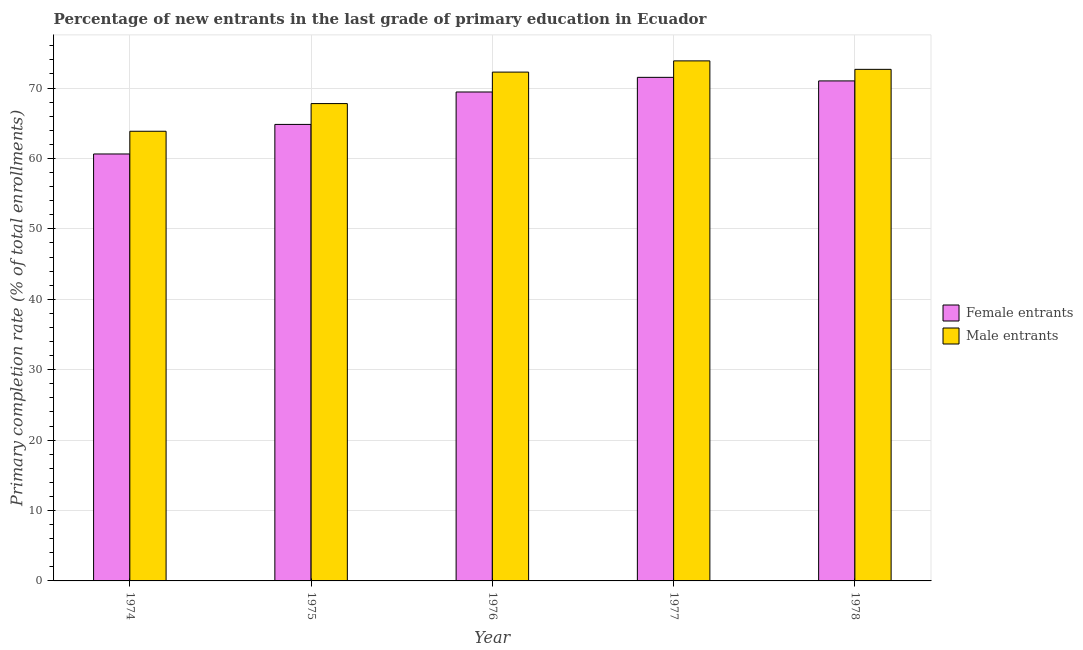How many different coloured bars are there?
Ensure brevity in your answer.  2. How many groups of bars are there?
Offer a very short reply. 5. Are the number of bars per tick equal to the number of legend labels?
Your answer should be very brief. Yes. How many bars are there on the 2nd tick from the left?
Your answer should be compact. 2. How many bars are there on the 2nd tick from the right?
Provide a short and direct response. 2. What is the label of the 4th group of bars from the left?
Ensure brevity in your answer.  1977. In how many cases, is the number of bars for a given year not equal to the number of legend labels?
Your response must be concise. 0. What is the primary completion rate of female entrants in 1978?
Ensure brevity in your answer.  71.01. Across all years, what is the maximum primary completion rate of female entrants?
Offer a terse response. 71.52. Across all years, what is the minimum primary completion rate of female entrants?
Your response must be concise. 60.64. In which year was the primary completion rate of male entrants minimum?
Make the answer very short. 1974. What is the total primary completion rate of female entrants in the graph?
Ensure brevity in your answer.  337.44. What is the difference between the primary completion rate of female entrants in 1974 and that in 1977?
Give a very brief answer. -10.88. What is the difference between the primary completion rate of female entrants in 1975 and the primary completion rate of male entrants in 1977?
Provide a succinct answer. -6.68. What is the average primary completion rate of female entrants per year?
Offer a very short reply. 67.49. What is the ratio of the primary completion rate of female entrants in 1974 to that in 1976?
Your answer should be very brief. 0.87. Is the primary completion rate of male entrants in 1974 less than that in 1976?
Your response must be concise. Yes. Is the difference between the primary completion rate of male entrants in 1974 and 1977 greater than the difference between the primary completion rate of female entrants in 1974 and 1977?
Offer a terse response. No. What is the difference between the highest and the second highest primary completion rate of male entrants?
Your answer should be compact. 1.2. What is the difference between the highest and the lowest primary completion rate of male entrants?
Your response must be concise. 10. In how many years, is the primary completion rate of female entrants greater than the average primary completion rate of female entrants taken over all years?
Keep it short and to the point. 3. What does the 2nd bar from the left in 1977 represents?
Make the answer very short. Male entrants. What does the 2nd bar from the right in 1976 represents?
Provide a succinct answer. Female entrants. How many years are there in the graph?
Keep it short and to the point. 5. What is the difference between two consecutive major ticks on the Y-axis?
Provide a succinct answer. 10. Are the values on the major ticks of Y-axis written in scientific E-notation?
Keep it short and to the point. No. Does the graph contain any zero values?
Make the answer very short. No. Does the graph contain grids?
Provide a succinct answer. Yes. Where does the legend appear in the graph?
Ensure brevity in your answer.  Center right. What is the title of the graph?
Make the answer very short. Percentage of new entrants in the last grade of primary education in Ecuador. What is the label or title of the X-axis?
Provide a succinct answer. Year. What is the label or title of the Y-axis?
Provide a succinct answer. Primary completion rate (% of total enrollments). What is the Primary completion rate (% of total enrollments) of Female entrants in 1974?
Keep it short and to the point. 60.64. What is the Primary completion rate (% of total enrollments) in Male entrants in 1974?
Your answer should be compact. 63.86. What is the Primary completion rate (% of total enrollments) in Female entrants in 1975?
Give a very brief answer. 64.83. What is the Primary completion rate (% of total enrollments) in Male entrants in 1975?
Provide a succinct answer. 67.79. What is the Primary completion rate (% of total enrollments) of Female entrants in 1976?
Give a very brief answer. 69.44. What is the Primary completion rate (% of total enrollments) in Male entrants in 1976?
Provide a short and direct response. 72.26. What is the Primary completion rate (% of total enrollments) in Female entrants in 1977?
Make the answer very short. 71.52. What is the Primary completion rate (% of total enrollments) in Male entrants in 1977?
Provide a short and direct response. 73.86. What is the Primary completion rate (% of total enrollments) in Female entrants in 1978?
Give a very brief answer. 71.01. What is the Primary completion rate (% of total enrollments) in Male entrants in 1978?
Offer a very short reply. 72.65. Across all years, what is the maximum Primary completion rate (% of total enrollments) in Female entrants?
Your answer should be very brief. 71.52. Across all years, what is the maximum Primary completion rate (% of total enrollments) in Male entrants?
Your response must be concise. 73.86. Across all years, what is the minimum Primary completion rate (% of total enrollments) of Female entrants?
Offer a terse response. 60.64. Across all years, what is the minimum Primary completion rate (% of total enrollments) of Male entrants?
Give a very brief answer. 63.86. What is the total Primary completion rate (% of total enrollments) of Female entrants in the graph?
Give a very brief answer. 337.44. What is the total Primary completion rate (% of total enrollments) of Male entrants in the graph?
Make the answer very short. 350.43. What is the difference between the Primary completion rate (% of total enrollments) of Female entrants in 1974 and that in 1975?
Your answer should be compact. -4.2. What is the difference between the Primary completion rate (% of total enrollments) in Male entrants in 1974 and that in 1975?
Keep it short and to the point. -3.93. What is the difference between the Primary completion rate (% of total enrollments) in Female entrants in 1974 and that in 1976?
Provide a short and direct response. -8.8. What is the difference between the Primary completion rate (% of total enrollments) in Male entrants in 1974 and that in 1976?
Your answer should be compact. -8.4. What is the difference between the Primary completion rate (% of total enrollments) in Female entrants in 1974 and that in 1977?
Make the answer very short. -10.88. What is the difference between the Primary completion rate (% of total enrollments) of Male entrants in 1974 and that in 1977?
Ensure brevity in your answer.  -10. What is the difference between the Primary completion rate (% of total enrollments) of Female entrants in 1974 and that in 1978?
Keep it short and to the point. -10.37. What is the difference between the Primary completion rate (% of total enrollments) of Male entrants in 1974 and that in 1978?
Your answer should be compact. -8.79. What is the difference between the Primary completion rate (% of total enrollments) in Female entrants in 1975 and that in 1976?
Your answer should be compact. -4.6. What is the difference between the Primary completion rate (% of total enrollments) in Male entrants in 1975 and that in 1976?
Your response must be concise. -4.47. What is the difference between the Primary completion rate (% of total enrollments) of Female entrants in 1975 and that in 1977?
Give a very brief answer. -6.68. What is the difference between the Primary completion rate (% of total enrollments) of Male entrants in 1975 and that in 1977?
Make the answer very short. -6.06. What is the difference between the Primary completion rate (% of total enrollments) of Female entrants in 1975 and that in 1978?
Provide a succinct answer. -6.18. What is the difference between the Primary completion rate (% of total enrollments) in Male entrants in 1975 and that in 1978?
Ensure brevity in your answer.  -4.86. What is the difference between the Primary completion rate (% of total enrollments) of Female entrants in 1976 and that in 1977?
Provide a short and direct response. -2.08. What is the difference between the Primary completion rate (% of total enrollments) in Male entrants in 1976 and that in 1977?
Ensure brevity in your answer.  -1.59. What is the difference between the Primary completion rate (% of total enrollments) in Female entrants in 1976 and that in 1978?
Provide a short and direct response. -1.57. What is the difference between the Primary completion rate (% of total enrollments) in Male entrants in 1976 and that in 1978?
Ensure brevity in your answer.  -0.39. What is the difference between the Primary completion rate (% of total enrollments) of Female entrants in 1977 and that in 1978?
Provide a succinct answer. 0.51. What is the difference between the Primary completion rate (% of total enrollments) of Male entrants in 1977 and that in 1978?
Offer a terse response. 1.2. What is the difference between the Primary completion rate (% of total enrollments) of Female entrants in 1974 and the Primary completion rate (% of total enrollments) of Male entrants in 1975?
Your answer should be very brief. -7.16. What is the difference between the Primary completion rate (% of total enrollments) of Female entrants in 1974 and the Primary completion rate (% of total enrollments) of Male entrants in 1976?
Your answer should be compact. -11.63. What is the difference between the Primary completion rate (% of total enrollments) in Female entrants in 1974 and the Primary completion rate (% of total enrollments) in Male entrants in 1977?
Your response must be concise. -13.22. What is the difference between the Primary completion rate (% of total enrollments) in Female entrants in 1974 and the Primary completion rate (% of total enrollments) in Male entrants in 1978?
Give a very brief answer. -12.02. What is the difference between the Primary completion rate (% of total enrollments) in Female entrants in 1975 and the Primary completion rate (% of total enrollments) in Male entrants in 1976?
Give a very brief answer. -7.43. What is the difference between the Primary completion rate (% of total enrollments) in Female entrants in 1975 and the Primary completion rate (% of total enrollments) in Male entrants in 1977?
Provide a succinct answer. -9.02. What is the difference between the Primary completion rate (% of total enrollments) of Female entrants in 1975 and the Primary completion rate (% of total enrollments) of Male entrants in 1978?
Keep it short and to the point. -7.82. What is the difference between the Primary completion rate (% of total enrollments) of Female entrants in 1976 and the Primary completion rate (% of total enrollments) of Male entrants in 1977?
Keep it short and to the point. -4.42. What is the difference between the Primary completion rate (% of total enrollments) in Female entrants in 1976 and the Primary completion rate (% of total enrollments) in Male entrants in 1978?
Your response must be concise. -3.22. What is the difference between the Primary completion rate (% of total enrollments) of Female entrants in 1977 and the Primary completion rate (% of total enrollments) of Male entrants in 1978?
Make the answer very short. -1.14. What is the average Primary completion rate (% of total enrollments) in Female entrants per year?
Make the answer very short. 67.49. What is the average Primary completion rate (% of total enrollments) in Male entrants per year?
Your answer should be compact. 70.09. In the year 1974, what is the difference between the Primary completion rate (% of total enrollments) of Female entrants and Primary completion rate (% of total enrollments) of Male entrants?
Your answer should be compact. -3.22. In the year 1975, what is the difference between the Primary completion rate (% of total enrollments) in Female entrants and Primary completion rate (% of total enrollments) in Male entrants?
Provide a succinct answer. -2.96. In the year 1976, what is the difference between the Primary completion rate (% of total enrollments) of Female entrants and Primary completion rate (% of total enrollments) of Male entrants?
Offer a very short reply. -2.83. In the year 1977, what is the difference between the Primary completion rate (% of total enrollments) of Female entrants and Primary completion rate (% of total enrollments) of Male entrants?
Your answer should be very brief. -2.34. In the year 1978, what is the difference between the Primary completion rate (% of total enrollments) in Female entrants and Primary completion rate (% of total enrollments) in Male entrants?
Your answer should be compact. -1.64. What is the ratio of the Primary completion rate (% of total enrollments) of Female entrants in 1974 to that in 1975?
Provide a succinct answer. 0.94. What is the ratio of the Primary completion rate (% of total enrollments) in Male entrants in 1974 to that in 1975?
Keep it short and to the point. 0.94. What is the ratio of the Primary completion rate (% of total enrollments) of Female entrants in 1974 to that in 1976?
Offer a terse response. 0.87. What is the ratio of the Primary completion rate (% of total enrollments) in Male entrants in 1974 to that in 1976?
Provide a succinct answer. 0.88. What is the ratio of the Primary completion rate (% of total enrollments) in Female entrants in 1974 to that in 1977?
Give a very brief answer. 0.85. What is the ratio of the Primary completion rate (% of total enrollments) in Male entrants in 1974 to that in 1977?
Offer a terse response. 0.86. What is the ratio of the Primary completion rate (% of total enrollments) of Female entrants in 1974 to that in 1978?
Make the answer very short. 0.85. What is the ratio of the Primary completion rate (% of total enrollments) of Male entrants in 1974 to that in 1978?
Your answer should be very brief. 0.88. What is the ratio of the Primary completion rate (% of total enrollments) of Female entrants in 1975 to that in 1976?
Your answer should be compact. 0.93. What is the ratio of the Primary completion rate (% of total enrollments) of Male entrants in 1975 to that in 1976?
Provide a succinct answer. 0.94. What is the ratio of the Primary completion rate (% of total enrollments) in Female entrants in 1975 to that in 1977?
Your answer should be very brief. 0.91. What is the ratio of the Primary completion rate (% of total enrollments) of Male entrants in 1975 to that in 1977?
Offer a very short reply. 0.92. What is the ratio of the Primary completion rate (% of total enrollments) of Male entrants in 1975 to that in 1978?
Offer a terse response. 0.93. What is the ratio of the Primary completion rate (% of total enrollments) of Female entrants in 1976 to that in 1977?
Your response must be concise. 0.97. What is the ratio of the Primary completion rate (% of total enrollments) in Male entrants in 1976 to that in 1977?
Your answer should be very brief. 0.98. What is the ratio of the Primary completion rate (% of total enrollments) in Female entrants in 1976 to that in 1978?
Provide a succinct answer. 0.98. What is the ratio of the Primary completion rate (% of total enrollments) in Female entrants in 1977 to that in 1978?
Your response must be concise. 1.01. What is the ratio of the Primary completion rate (% of total enrollments) of Male entrants in 1977 to that in 1978?
Provide a succinct answer. 1.02. What is the difference between the highest and the second highest Primary completion rate (% of total enrollments) in Female entrants?
Keep it short and to the point. 0.51. What is the difference between the highest and the second highest Primary completion rate (% of total enrollments) in Male entrants?
Your answer should be compact. 1.2. What is the difference between the highest and the lowest Primary completion rate (% of total enrollments) of Female entrants?
Make the answer very short. 10.88. What is the difference between the highest and the lowest Primary completion rate (% of total enrollments) of Male entrants?
Your answer should be very brief. 10. 